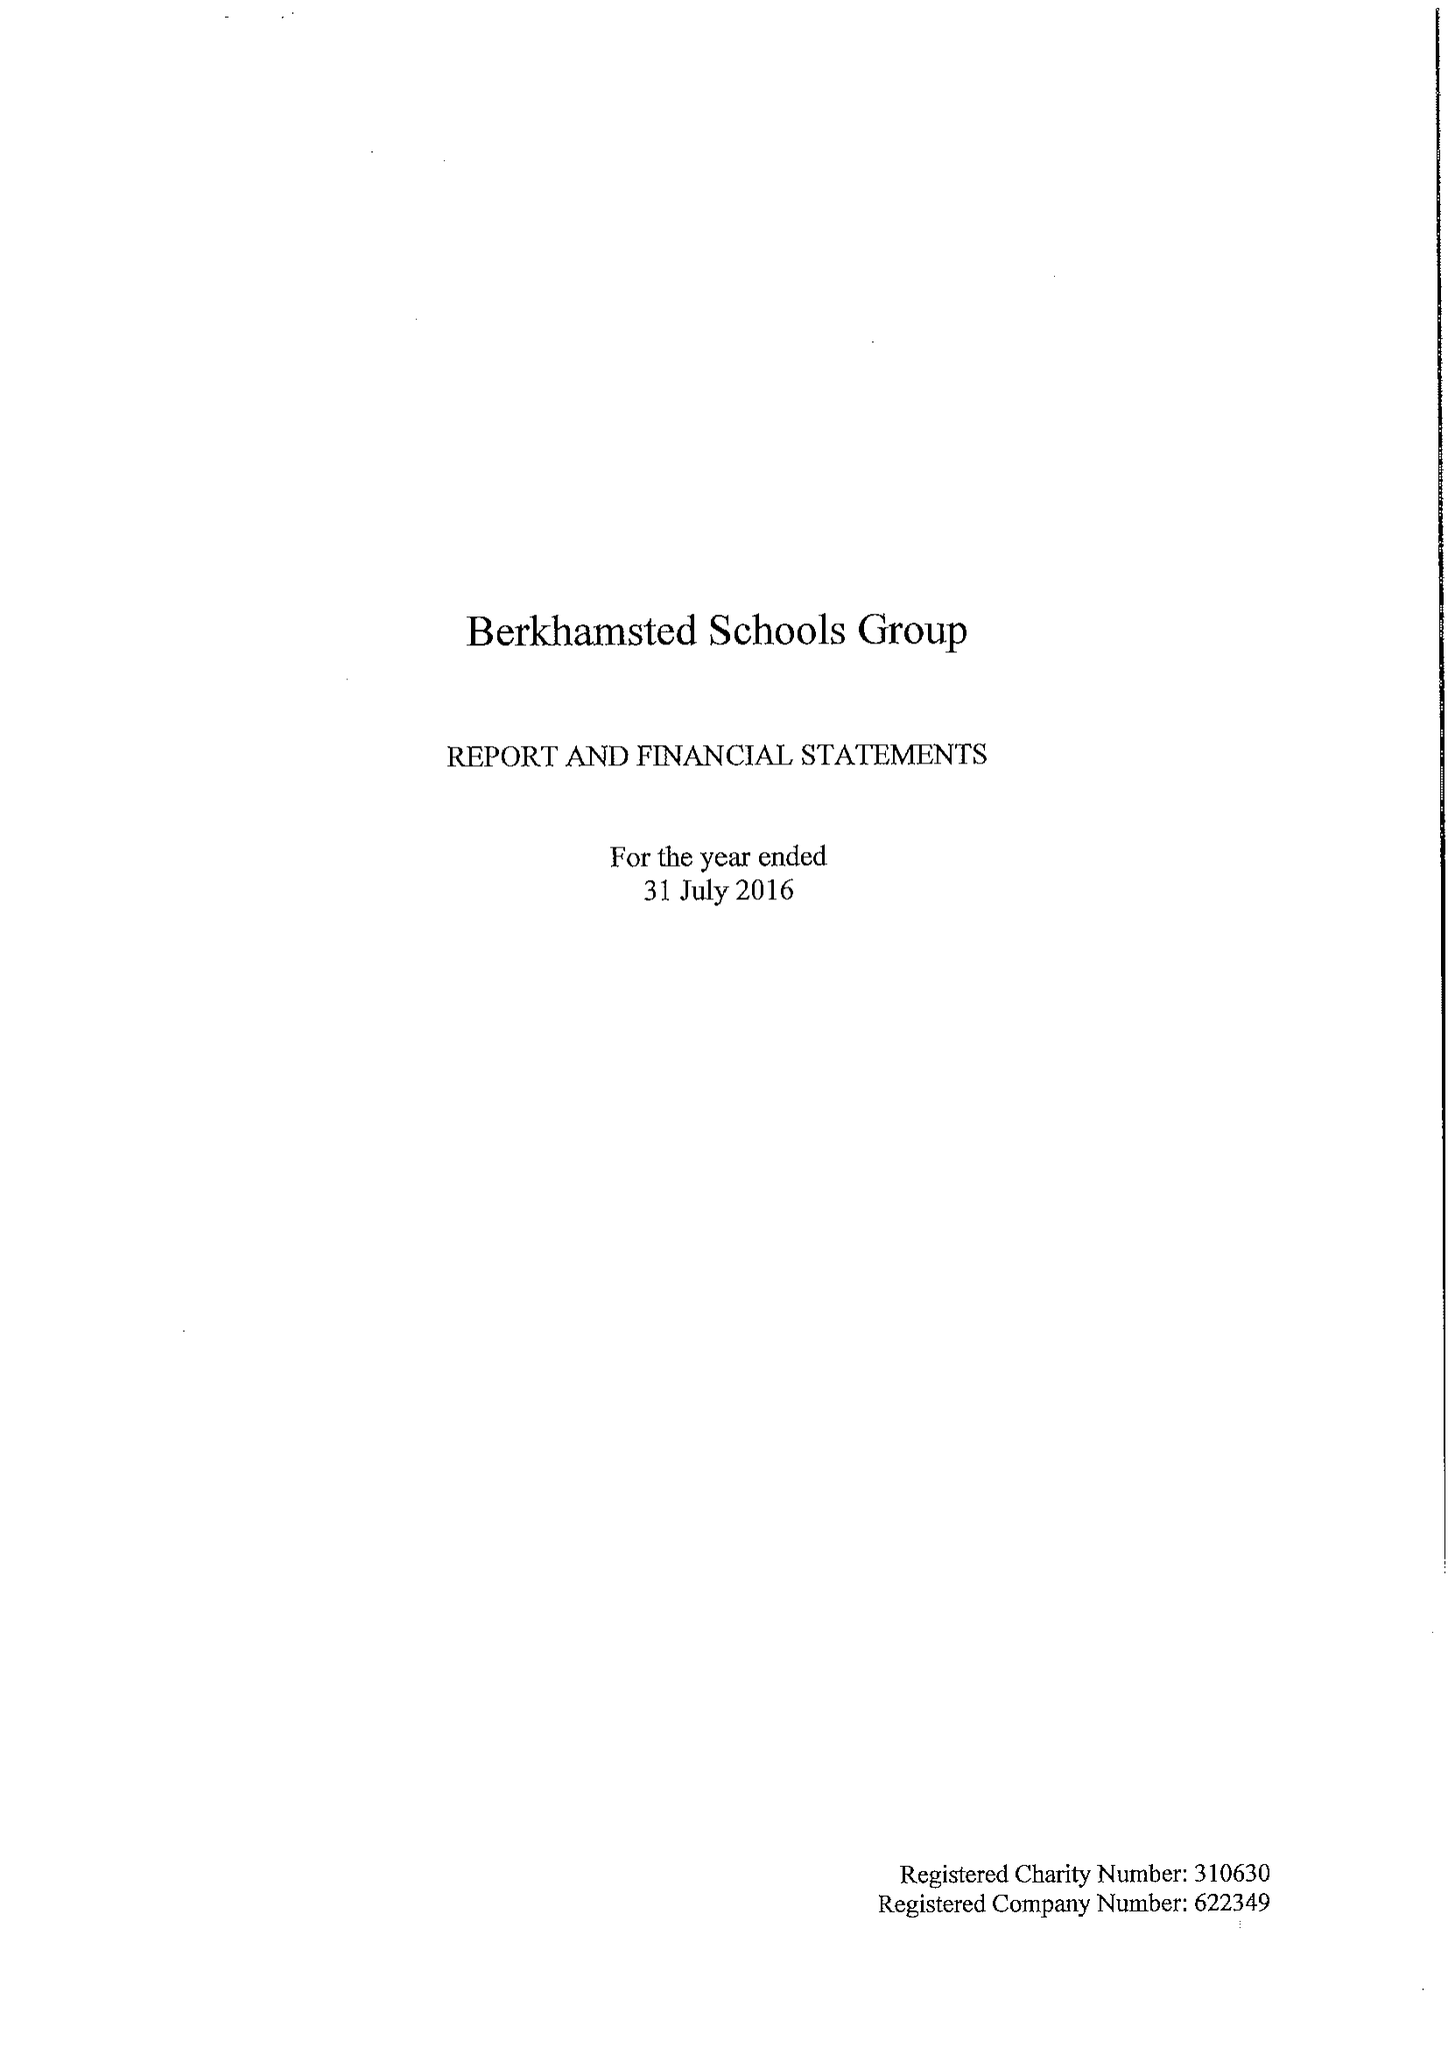What is the value for the address__postcode?
Answer the question using a single word or phrase. HP4 3AA 